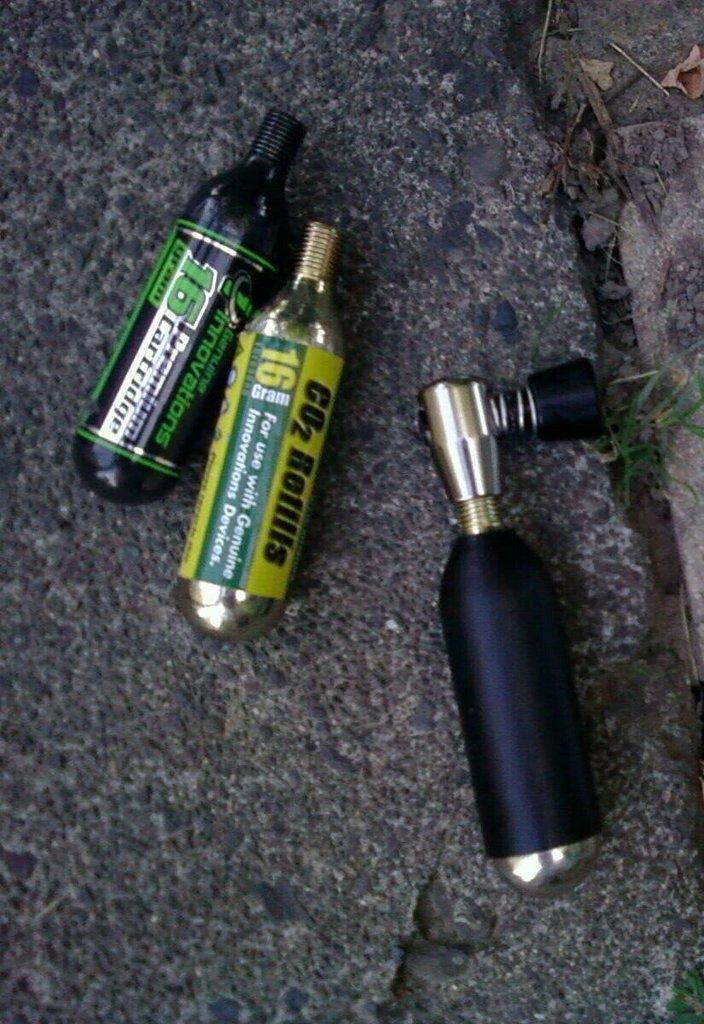In one or two sentences, can you explain what this image depicts? In this picture we can see few bottles on the ground. 